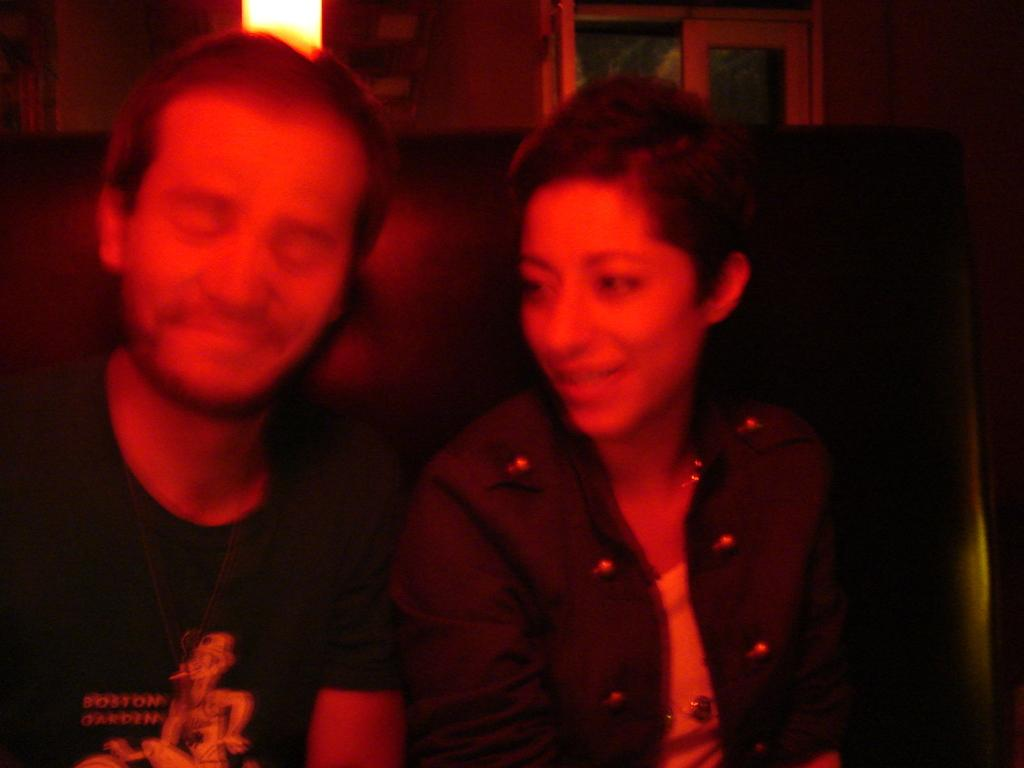What are the people in the image doing? The people in the image are sitting on a couch. What can be seen in the background of the image? There is a light and windows visible in the background of the image. How many cakes are being served at the funeral in the image? There is no funeral or cakes present in the image; it simply shows people sitting on a couch with a light and windows in the background. 